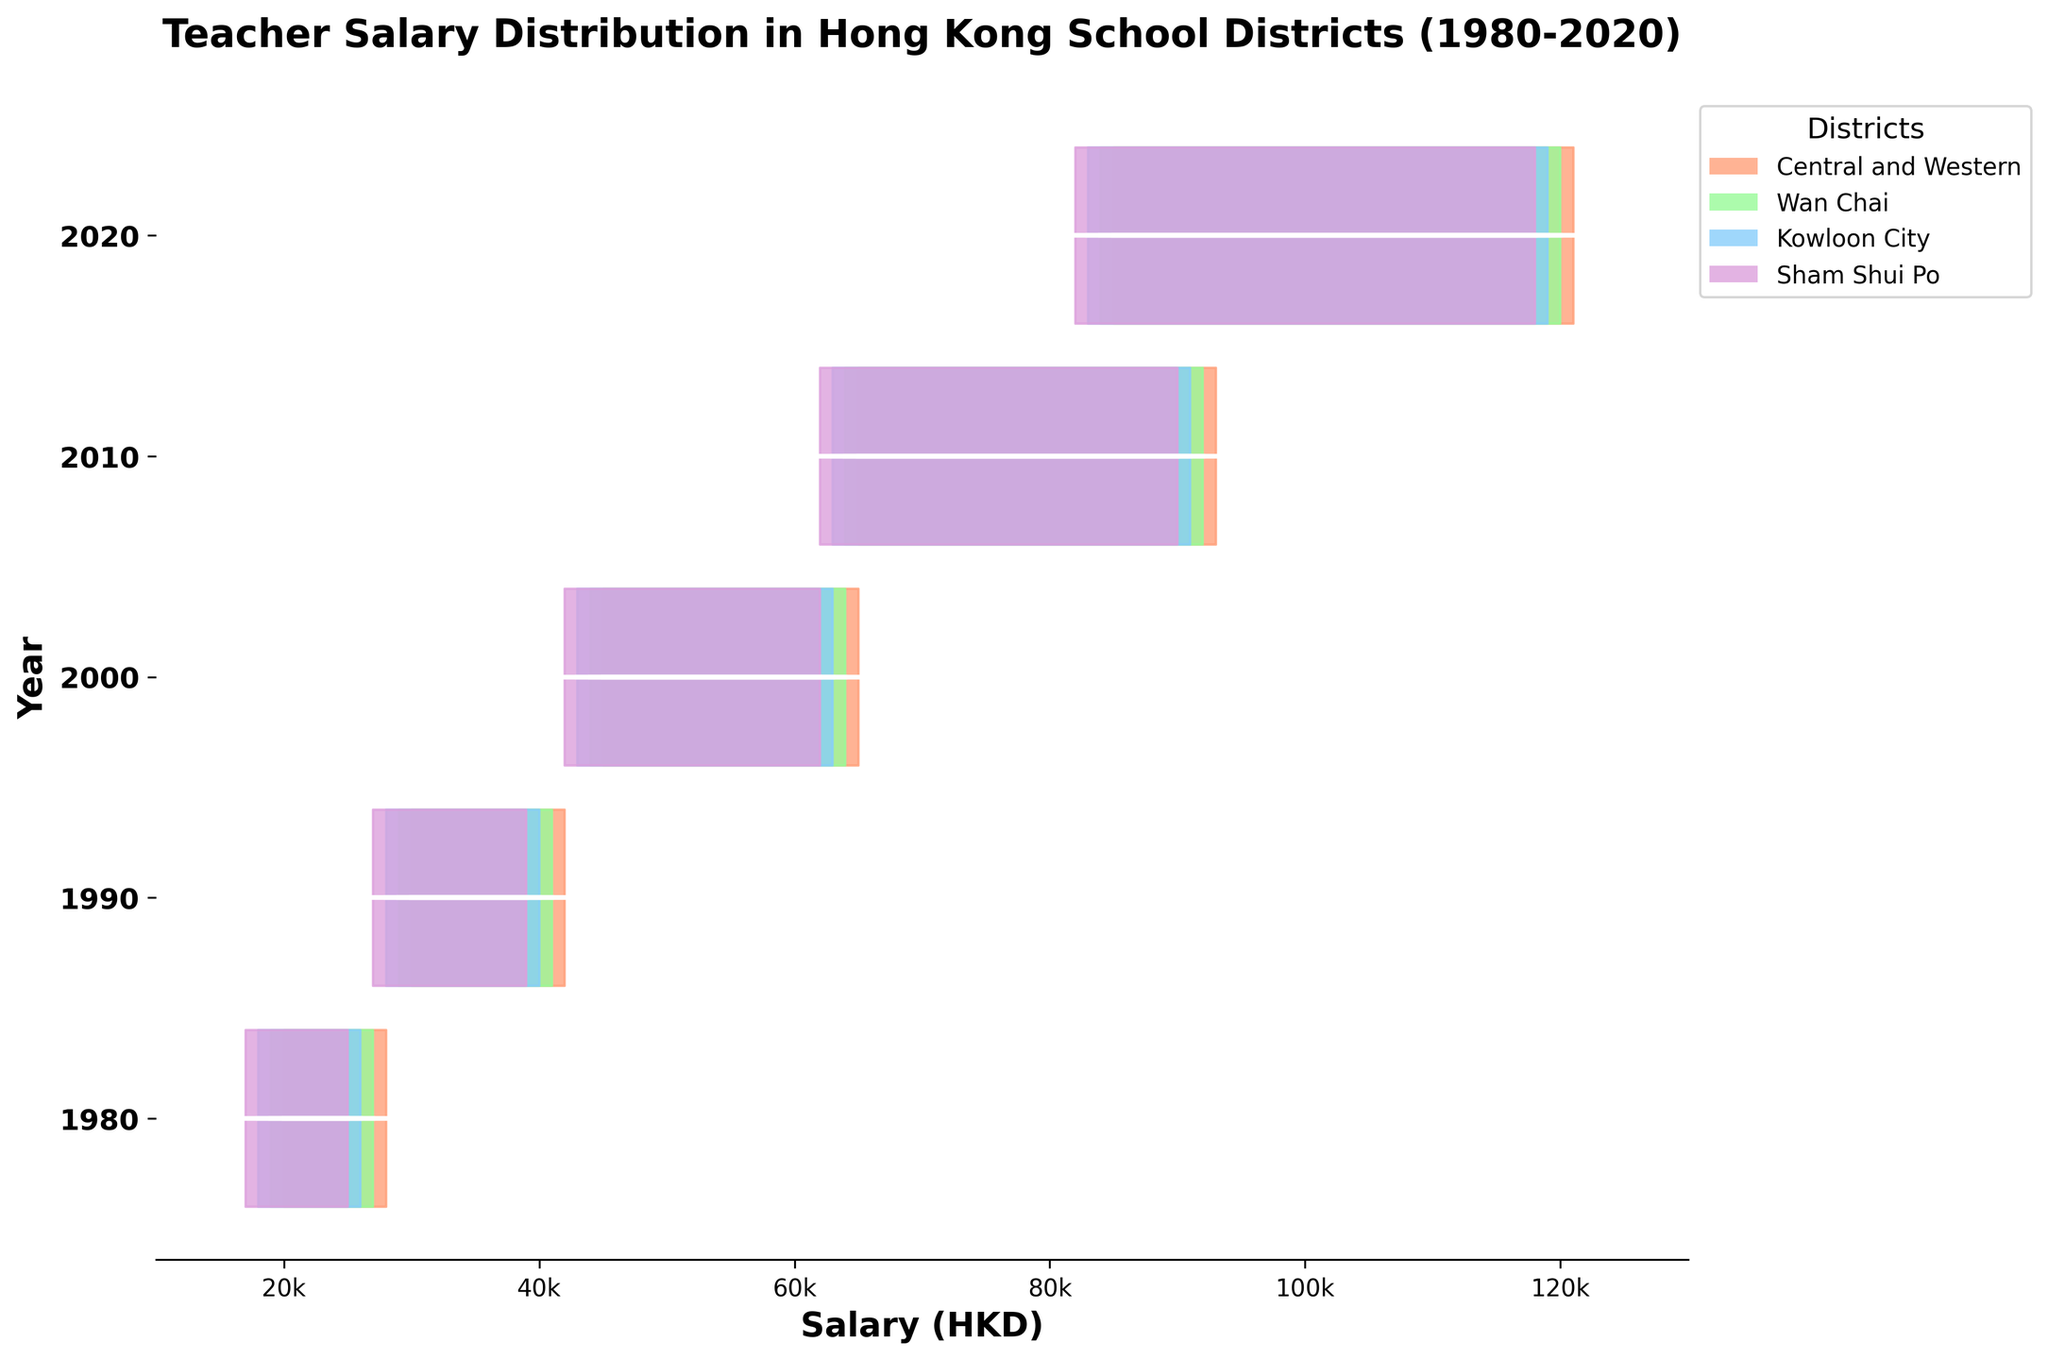What is the title of the figure? The title is usually positioned at the top of the figure and is set in larger, bold font.
Answer: Teacher Salary Distribution in Hong Kong School Districts (1980-2020) Which year had the highest teacher salaries? By looking at the highest peaks of the salary distributions at each year, 2020 has the highest salaries, reaching up to 121,000 HKD.
Answer: 2020 What is the range of teacher salaries in 2000 for the Sham Shui Po district? The Sham Shui Po district in 2000 had salary distributions starting at 42,000 HKD and reaching up to 62,000 HKD. The range is calculated as 62,000 - 42,000.
Answer: 20,000 HKD Which district had the most consistent salary increase over the years? By examining the salary increases from 1980 to 2020, all districts show consistent growth, but Central and Western has the most notable and higher salaries consistently.
Answer: Central and Western How do the salary distributions in Wan Chai compare between 1980 and 2020? In 1980, salaries ranged from 19,000 to 27,000 HKD. In 2020, they ranged from 84,000 to 120,000 HKD, showing a substantial increase over this period.
Answer: Significant increase What is the average salary in Central and Western district in 2010? The salaries in 2010 for Central and Western are 65,000, 72,000, 79,000, 86,000, and 93,000. The average is calculated by summing these values and dividing by 5: (65000 + 72000 + 79000 + 86000 + 93000) / 5.
Answer: 79,200 HKD Which district had the lowest salary distribution in 1990? Examining the plotted salaries of 1990, Sham Shui Po had the lowest distribution with salaries ranging from 27,000 to 39,000 HKD.
Answer: Sham Shui Po What trend do you observe in teacher salaries from 1980 to 2020? The general trend visible in all districts shows a steady and significant increase in salaries across all the years.
Answer: Steady increase In terms of salary distribution, which year shows the greatest spread (range) in the Central and Western district? The spreads can be observed by looking at the distance between the minimum and maximum values. For Central and Western, the greatest spread is in 2020 (121,000 - 85,000).
Answer: 2020 How do the salaries in Kowloon City in 1990 compare to those in 2000? In 1990, Kowloon City's salaries ranged from 28,000 to 40,000 HKD. In 2000, they ranged from 43,000 to 63,000 HKD, showing a clear increase over the decade.
Answer: Higher in 2000 